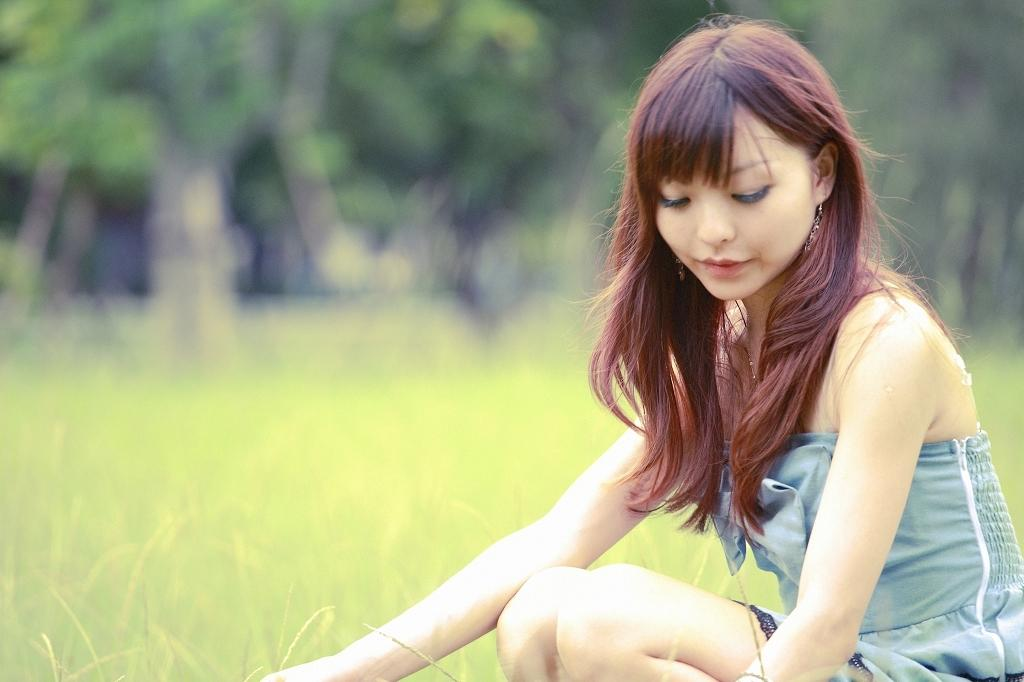Who is in the image? There is a girl in the image. What is the girl's expression? The girl is smiling. What can be seen in the background of the image? There is grass and trees in the background of the image. How would you describe the background of the image? The background is blurry. What type of appliance can be seen in the image? There is no appliance present in the image. How does the fan affect the girl's hair in the image? There is no fan present in the image, so it cannot affect the girl's hair. 